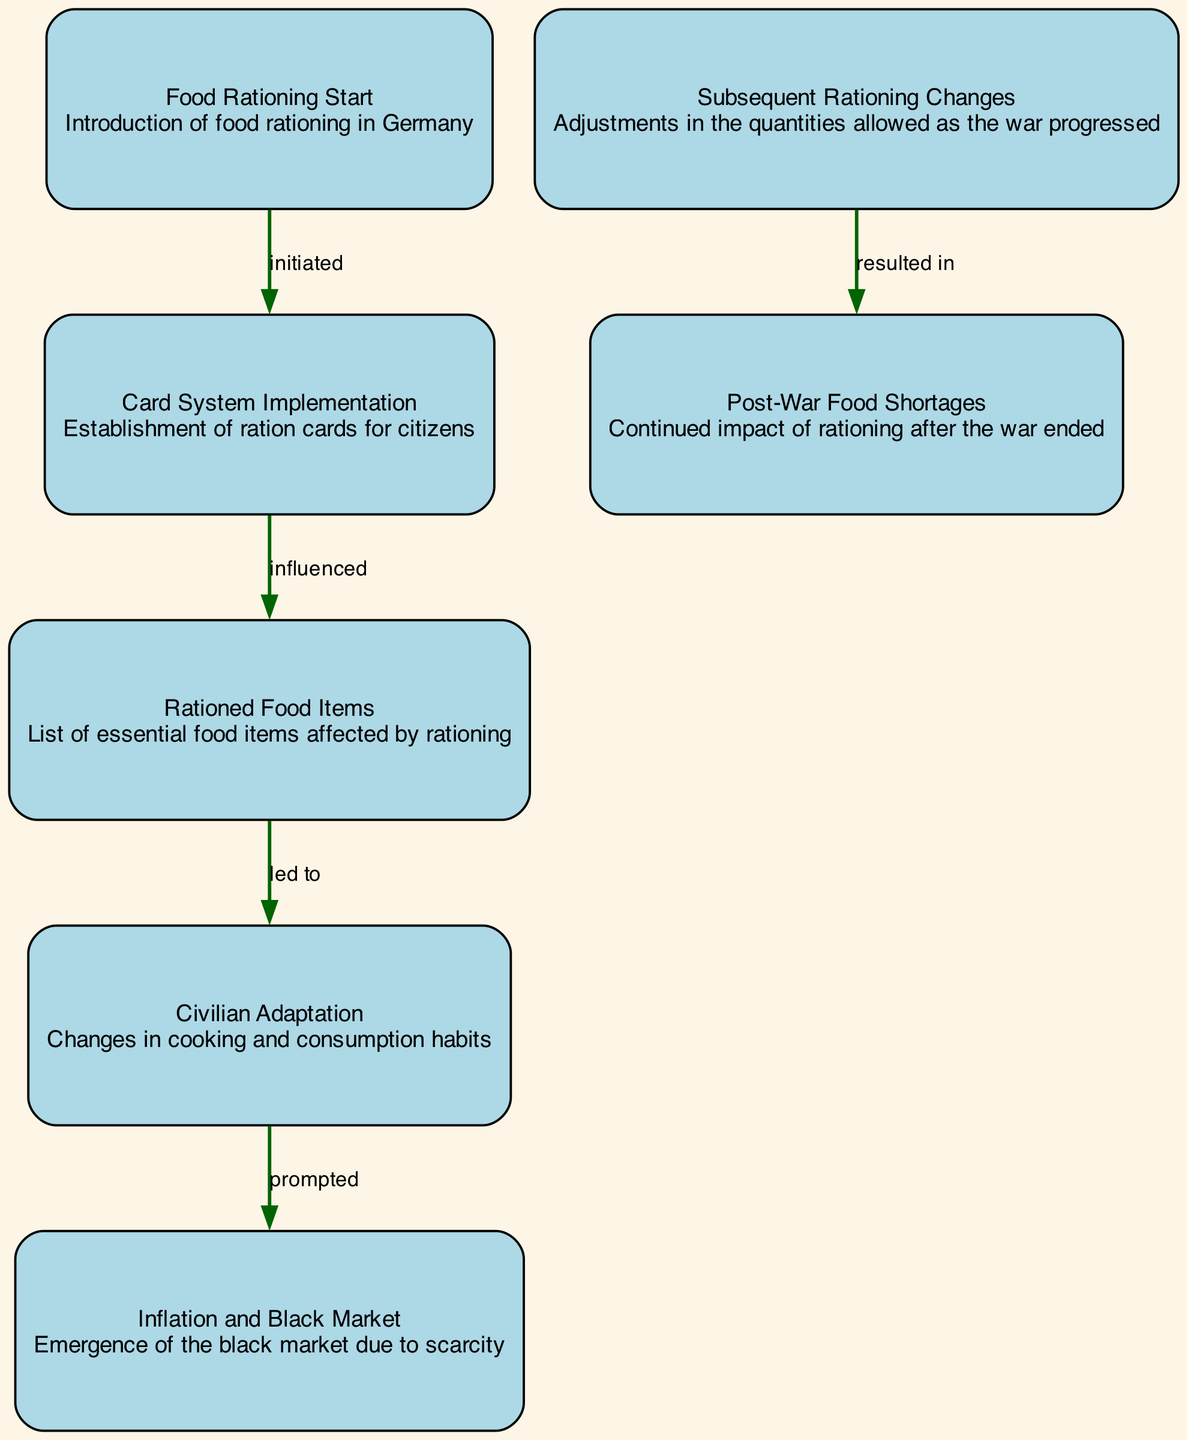What is the first event in the diagram? The first event in the diagram is the "Food Rationing Start," which marks the introduction of food rationing in Germany. This is represented by the first node in the directed graph.
Answer: Food Rationing Start How many nodes are there in total? The diagram contains a total of seven nodes, each representing different aspects of food rationing during the war. This can be counted directly from the nodes list provided.
Answer: Seven What relationship does "Card System Implementation" have with the previous node? The "Card System Implementation" node is directly influenced by the "Food Rationing Start" node, indicating that the initiation of rationing led to this system's establishment. The edge connects these two nodes with the label "initiated."
Answer: Influenced Which node leads to civilian adaptations in food consumption? The node "Rationed Food Items" leads directly to "Civilian Adaptation," indicating that the impact of the rationed food items prompted changes in the cooking and consumption habits of civilians.
Answer: Civilian Adaptation What does the "Inflation and Black Market" node indicate in terms of civilian response? The "Inflation and Black Market" node indicates that it was prompted by the changes in cooking and consumption habits, showing how scarcity led to illegal market activity as civilians sought additional food resources.
Answer: Prompted What resulted from subsequent rationing changes? The node "Subsequent Rationing Changes" resulted in "Post-War Food Shortages," indicating that the adjustments in ration quantities during the war had lasting impacts even after its conclusion.
Answer: Resulted in What type of changes did civilians make regarding food? Civilians made "changes in cooking and consumption habits" as highlighted in the "Civilian Adaptation" node, showing their resilience and adjustments due to rationing challenges.
Answer: Changes in cooking and consumption habits 